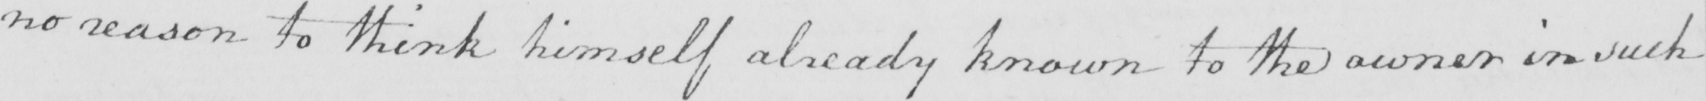What text is written in this handwritten line? no reason to think himself already known to the owner in such 